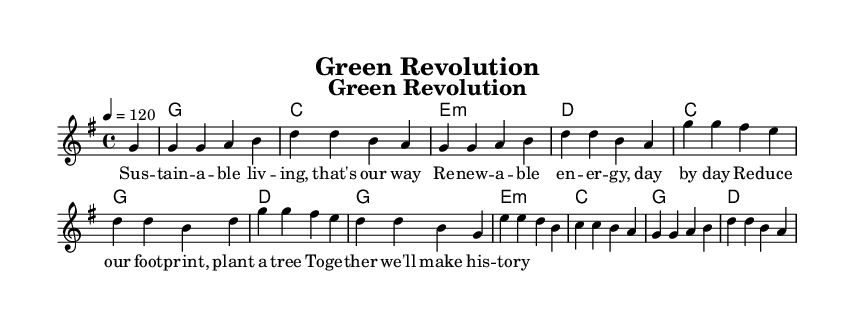What is the key signature of this music? The key signature is G major, which has one sharp (F#) as indicated at the beginning of the score.
Answer: G major What is the time signature of this music? The time signature shows that there are four beats per measure, indicated by the 4/4 notation at the beginning.
Answer: 4/4 What is the tempo indication of this music? The tempo is indicated as 120 beats per minute, specified at the start of the score as "4 = 120."
Answer: 120 How many measures are there in the melody? By counting the distinct segments separated by vertical lines in the melody section, we find there are a total of 12 measures.
Answer: 12 What type of lyrics are used in this song? The lyrics follow a repetitive and positive theme centered around sustainability and eco-friendly practices, which aligns with the upbeat nature of the country rock genre.
Answer: Upbeat and positive Which chord is used after the first measure? Looking at the harmonies section, the chord following the first measure is G major as represented by the notation 'g1.'
Answer: G major What is the overall theme of the lyrics? The lyrics focus on sustainable living and the importance of renewable energy, promoting eco-friendly practices through a positive message.
Answer: Sustainable living 